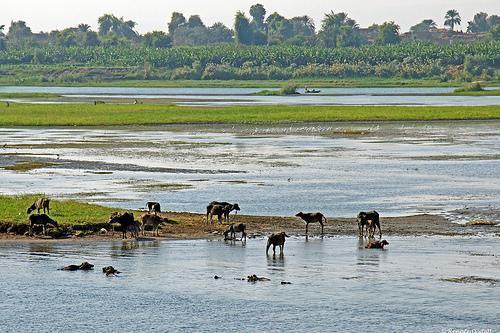How many boats?
Give a very brief answer. 1. 